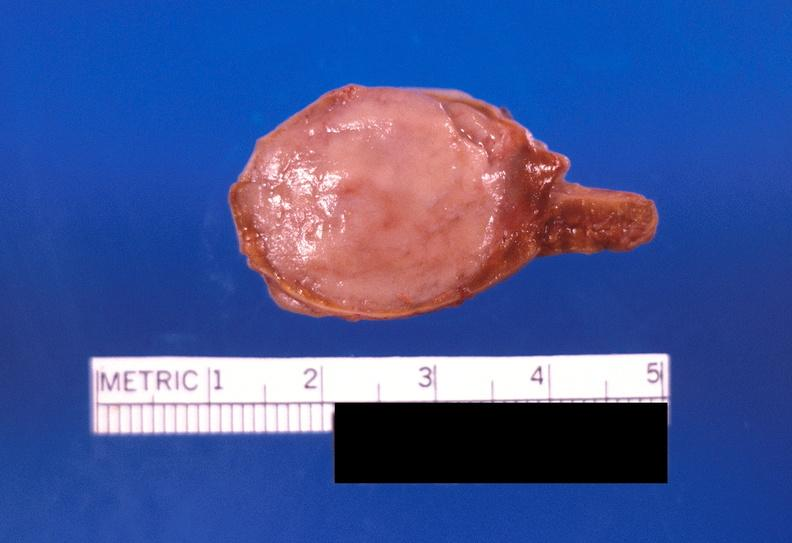does carcinomatosis show adrenal medullary tumor?
Answer the question using a single word or phrase. No 